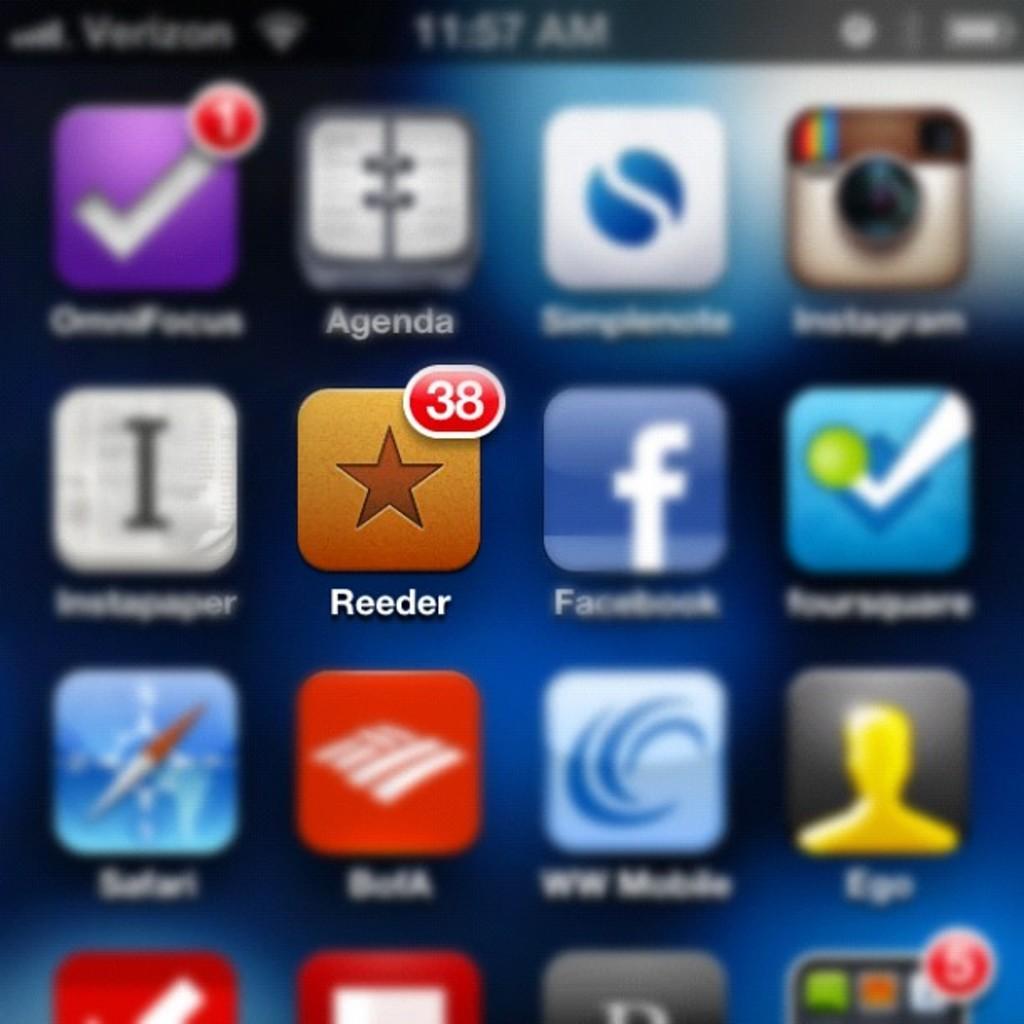What app is in focus?
Your response must be concise. Reeder. What is the app that is in focus?
Give a very brief answer. Reeder. 